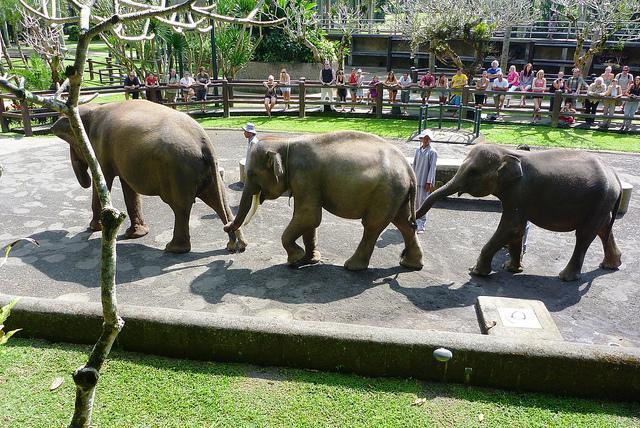How many elephants are there?
Give a very brief answer. 3. 